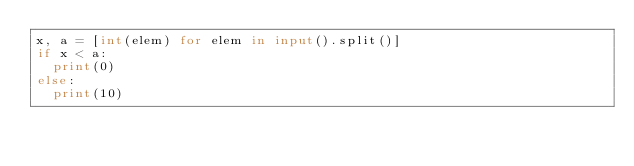<code> <loc_0><loc_0><loc_500><loc_500><_Python_>x, a = [int(elem) for elem in input().split()]
if x < a:
  print(0)
else:
  print(10)</code> 